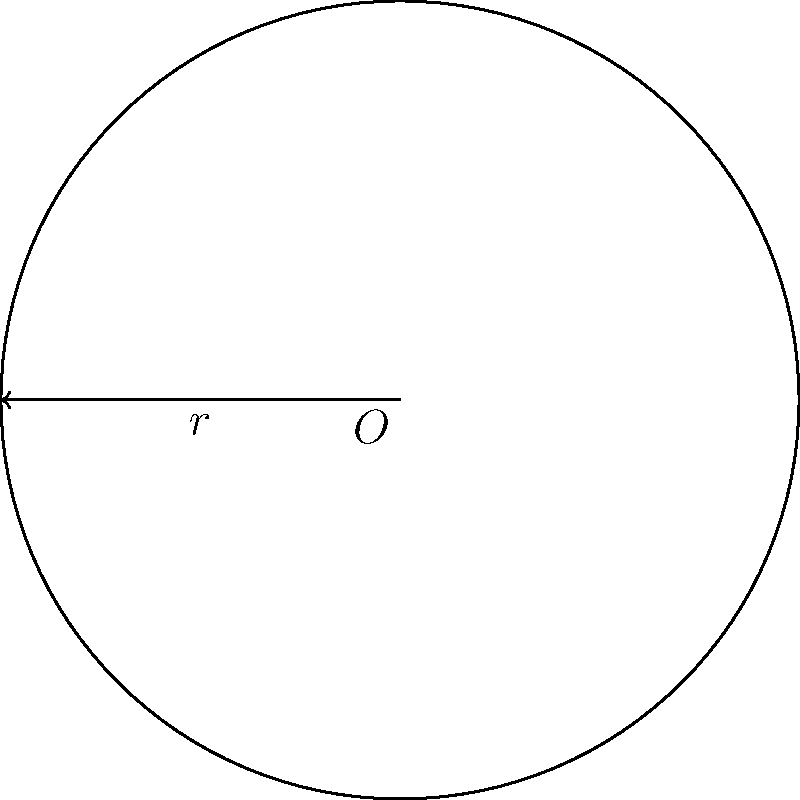Hey, remember when we used to hang out at Barb's place after school? I've got this math problem about circles, and I thought you might be able to help. If a circle has a radius of 6 units, what's its area? Can you walk me through it like you used to during our study sessions? Sure! Let's break it down step-by-step, just like we used to:

1) First, recall the formula for the area of a circle:
   $$A = \pi r^2$$
   where $A$ is the area and $r$ is the radius.

2) We're given that the radius is 6 units, so let's substitute that:
   $$A = \pi (6)^2$$

3) Now, let's simplify the exponent:
   $$A = \pi (36)$$

4) We could leave it like this, but let's calculate it for a more precise answer:
   $$A = 36\pi$$

5) If we want to approximate this with decimals, we can use 3.14159 for $\pi$:
   $$A \approx 36 \times 3.14159 \approx 113.097 \text{ square units}$$

So, the area of the circle is $36\pi$ square units, or approximately 113.097 square units.
Answer: $36\pi$ square units 